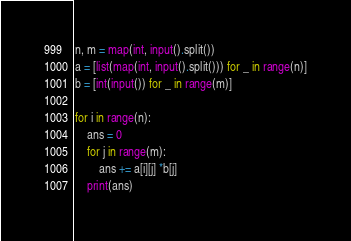<code> <loc_0><loc_0><loc_500><loc_500><_Python_>n, m = map(int, input().split())
a = [list(map(int, input().split())) for _ in range(n)]
b = [int(input()) for _ in range(m)]

for i in range(n):
    ans = 0
    for j in range(m):
        ans += a[i][j] *b[j]
    print(ans)
</code> 